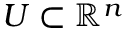Convert formula to latex. <formula><loc_0><loc_0><loc_500><loc_500>U \subset \mathbb { R } ^ { n }</formula> 